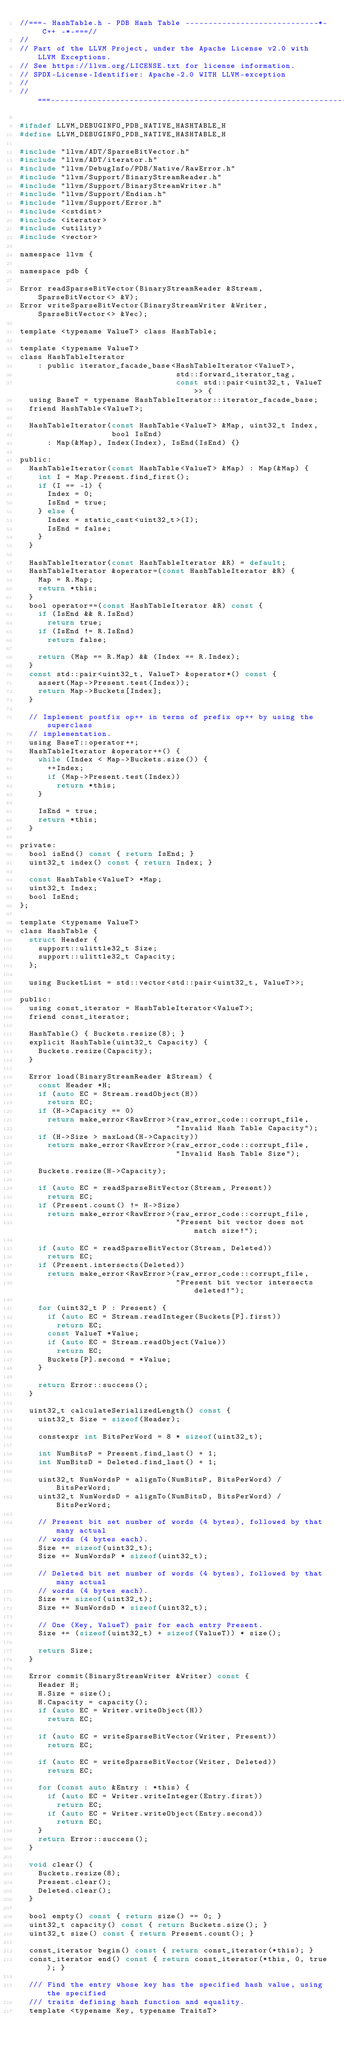Convert code to text. <code><loc_0><loc_0><loc_500><loc_500><_C_>//===- HashTable.h - PDB Hash Table -----------------------------*- C++ -*-===//
//
// Part of the LLVM Project, under the Apache License v2.0 with LLVM Exceptions.
// See https://llvm.org/LICENSE.txt for license information.
// SPDX-License-Identifier: Apache-2.0 WITH LLVM-exception
//
//===----------------------------------------------------------------------===//

#ifndef LLVM_DEBUGINFO_PDB_NATIVE_HASHTABLE_H
#define LLVM_DEBUGINFO_PDB_NATIVE_HASHTABLE_H

#include "llvm/ADT/SparseBitVector.h"
#include "llvm/ADT/iterator.h"
#include "llvm/DebugInfo/PDB/Native/RawError.h"
#include "llvm/Support/BinaryStreamReader.h"
#include "llvm/Support/BinaryStreamWriter.h"
#include "llvm/Support/Endian.h"
#include "llvm/Support/Error.h"
#include <cstdint>
#include <iterator>
#include <utility>
#include <vector>

namespace llvm {

namespace pdb {

Error readSparseBitVector(BinaryStreamReader &Stream, SparseBitVector<> &V);
Error writeSparseBitVector(BinaryStreamWriter &Writer, SparseBitVector<> &Vec);

template <typename ValueT> class HashTable;

template <typename ValueT>
class HashTableIterator
    : public iterator_facade_base<HashTableIterator<ValueT>,
                                  std::forward_iterator_tag,
                                  const std::pair<uint32_t, ValueT>> {
  using BaseT = typename HashTableIterator::iterator_facade_base;
  friend HashTable<ValueT>;

  HashTableIterator(const HashTable<ValueT> &Map, uint32_t Index,
                    bool IsEnd)
      : Map(&Map), Index(Index), IsEnd(IsEnd) {}

public:
  HashTableIterator(const HashTable<ValueT> &Map) : Map(&Map) {
    int I = Map.Present.find_first();
    if (I == -1) {
      Index = 0;
      IsEnd = true;
    } else {
      Index = static_cast<uint32_t>(I);
      IsEnd = false;
    }
  }

  HashTableIterator(const HashTableIterator &R) = default;
  HashTableIterator &operator=(const HashTableIterator &R) {
    Map = R.Map;
    return *this;
  }
  bool operator==(const HashTableIterator &R) const {
    if (IsEnd && R.IsEnd)
      return true;
    if (IsEnd != R.IsEnd)
      return false;

    return (Map == R.Map) && (Index == R.Index);
  }
  const std::pair<uint32_t, ValueT> &operator*() const {
    assert(Map->Present.test(Index));
    return Map->Buckets[Index];
  }

  // Implement postfix op++ in terms of prefix op++ by using the superclass
  // implementation.
  using BaseT::operator++;
  HashTableIterator &operator++() {
    while (Index < Map->Buckets.size()) {
      ++Index;
      if (Map->Present.test(Index))
        return *this;
    }

    IsEnd = true;
    return *this;
  }

private:
  bool isEnd() const { return IsEnd; }
  uint32_t index() const { return Index; }

  const HashTable<ValueT> *Map;
  uint32_t Index;
  bool IsEnd;
};

template <typename ValueT>
class HashTable {
  struct Header {
    support::ulittle32_t Size;
    support::ulittle32_t Capacity;
  };

  using BucketList = std::vector<std::pair<uint32_t, ValueT>>;

public:
  using const_iterator = HashTableIterator<ValueT>;
  friend const_iterator;

  HashTable() { Buckets.resize(8); }
  explicit HashTable(uint32_t Capacity) {
    Buckets.resize(Capacity);
  }

  Error load(BinaryStreamReader &Stream) {
    const Header *H;
    if (auto EC = Stream.readObject(H))
      return EC;
    if (H->Capacity == 0)
      return make_error<RawError>(raw_error_code::corrupt_file,
                                  "Invalid Hash Table Capacity");
    if (H->Size > maxLoad(H->Capacity))
      return make_error<RawError>(raw_error_code::corrupt_file,
                                  "Invalid Hash Table Size");

    Buckets.resize(H->Capacity);

    if (auto EC = readSparseBitVector(Stream, Present))
      return EC;
    if (Present.count() != H->Size)
      return make_error<RawError>(raw_error_code::corrupt_file,
                                  "Present bit vector does not match size!");

    if (auto EC = readSparseBitVector(Stream, Deleted))
      return EC;
    if (Present.intersects(Deleted))
      return make_error<RawError>(raw_error_code::corrupt_file,
                                  "Present bit vector intersects deleted!");

    for (uint32_t P : Present) {
      if (auto EC = Stream.readInteger(Buckets[P].first))
        return EC;
      const ValueT *Value;
      if (auto EC = Stream.readObject(Value))
        return EC;
      Buckets[P].second = *Value;
    }

    return Error::success();
  }

  uint32_t calculateSerializedLength() const {
    uint32_t Size = sizeof(Header);

    constexpr int BitsPerWord = 8 * sizeof(uint32_t);

    int NumBitsP = Present.find_last() + 1;
    int NumBitsD = Deleted.find_last() + 1;

    uint32_t NumWordsP = alignTo(NumBitsP, BitsPerWord) / BitsPerWord;
    uint32_t NumWordsD = alignTo(NumBitsD, BitsPerWord) / BitsPerWord;

    // Present bit set number of words (4 bytes), followed by that many actual
    // words (4 bytes each).
    Size += sizeof(uint32_t);
    Size += NumWordsP * sizeof(uint32_t);

    // Deleted bit set number of words (4 bytes), followed by that many actual
    // words (4 bytes each).
    Size += sizeof(uint32_t);
    Size += NumWordsD * sizeof(uint32_t);

    // One (Key, ValueT) pair for each entry Present.
    Size += (sizeof(uint32_t) + sizeof(ValueT)) * size();

    return Size;
  }

  Error commit(BinaryStreamWriter &Writer) const {
    Header H;
    H.Size = size();
    H.Capacity = capacity();
    if (auto EC = Writer.writeObject(H))
      return EC;

    if (auto EC = writeSparseBitVector(Writer, Present))
      return EC;

    if (auto EC = writeSparseBitVector(Writer, Deleted))
      return EC;

    for (const auto &Entry : *this) {
      if (auto EC = Writer.writeInteger(Entry.first))
        return EC;
      if (auto EC = Writer.writeObject(Entry.second))
        return EC;
    }
    return Error::success();
  }

  void clear() {
    Buckets.resize(8);
    Present.clear();
    Deleted.clear();
  }

  bool empty() const { return size() == 0; }
  uint32_t capacity() const { return Buckets.size(); }
  uint32_t size() const { return Present.count(); }

  const_iterator begin() const { return const_iterator(*this); }
  const_iterator end() const { return const_iterator(*this, 0, true); }

  /// Find the entry whose key has the specified hash value, using the specified
  /// traits defining hash function and equality.
  template <typename Key, typename TraitsT></code> 